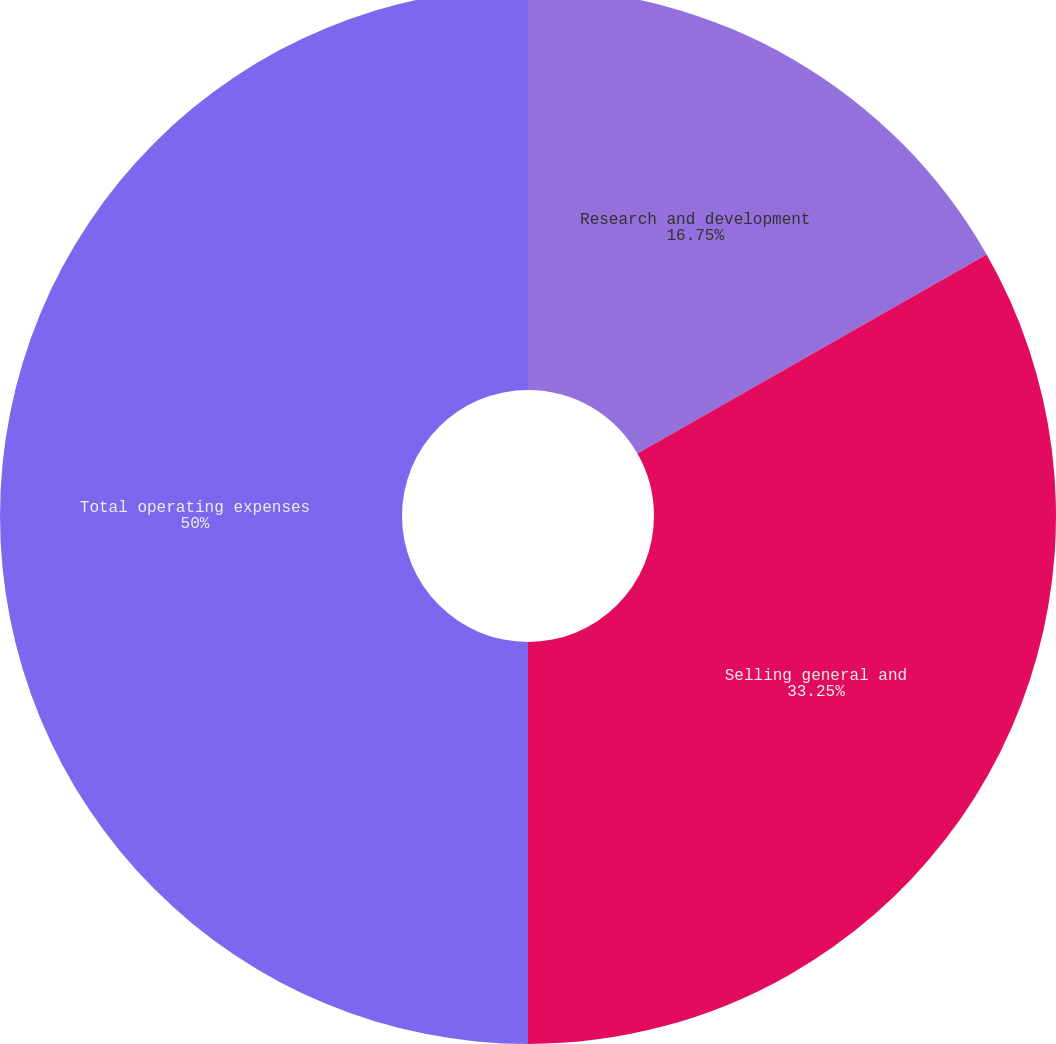Convert chart to OTSL. <chart><loc_0><loc_0><loc_500><loc_500><pie_chart><fcel>Research and development<fcel>Selling general and<fcel>Total operating expenses<nl><fcel>16.75%<fcel>33.25%<fcel>50.0%<nl></chart> 